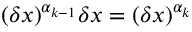<formula> <loc_0><loc_0><loc_500><loc_500>( \delta x ) ^ { \alpha _ { k - 1 } } \delta x = ( \delta x ) ^ { \alpha _ { k } }</formula> 